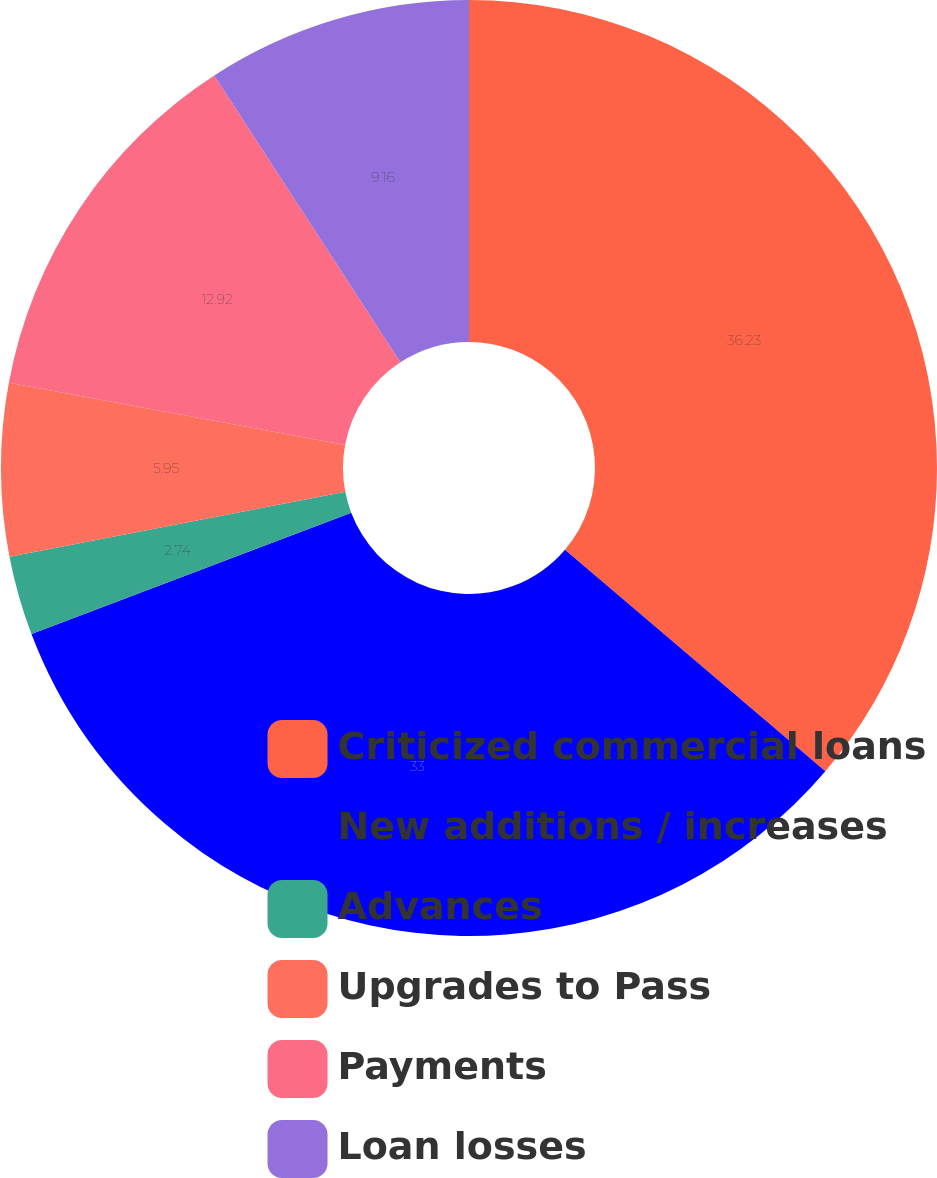Convert chart. <chart><loc_0><loc_0><loc_500><loc_500><pie_chart><fcel>Criticized commercial loans<fcel>New additions / increases<fcel>Advances<fcel>Upgrades to Pass<fcel>Payments<fcel>Loan losses<nl><fcel>36.22%<fcel>33.0%<fcel>2.74%<fcel>5.95%<fcel>12.92%<fcel>9.16%<nl></chart> 